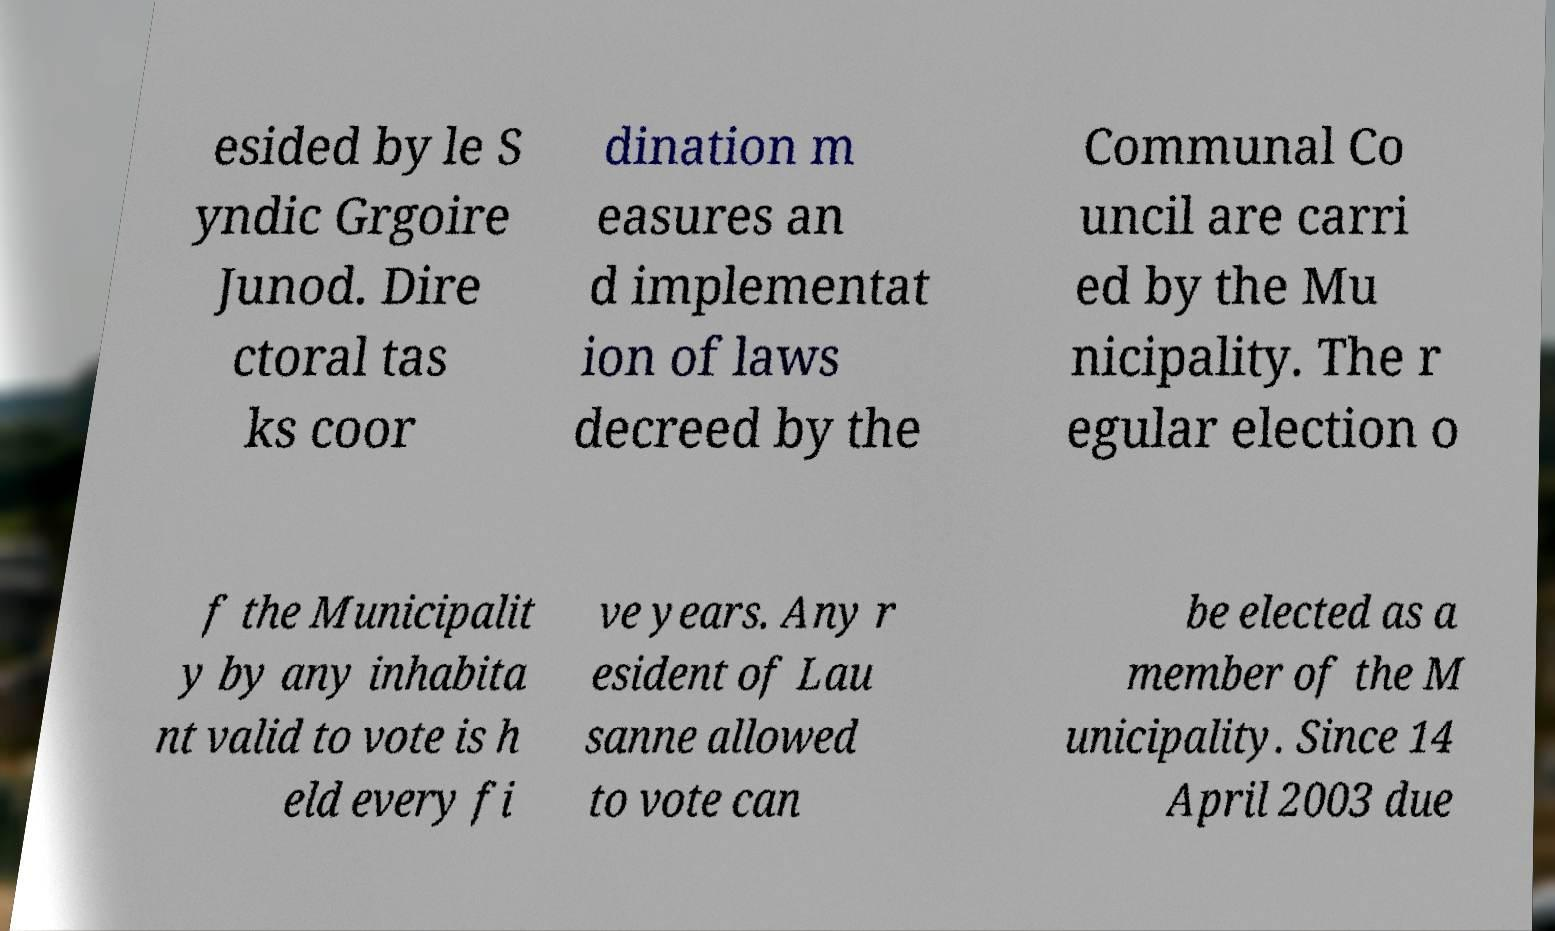What messages or text are displayed in this image? I need them in a readable, typed format. esided by le S yndic Grgoire Junod. Dire ctoral tas ks coor dination m easures an d implementat ion of laws decreed by the Communal Co uncil are carri ed by the Mu nicipality. The r egular election o f the Municipalit y by any inhabita nt valid to vote is h eld every fi ve years. Any r esident of Lau sanne allowed to vote can be elected as a member of the M unicipality. Since 14 April 2003 due 